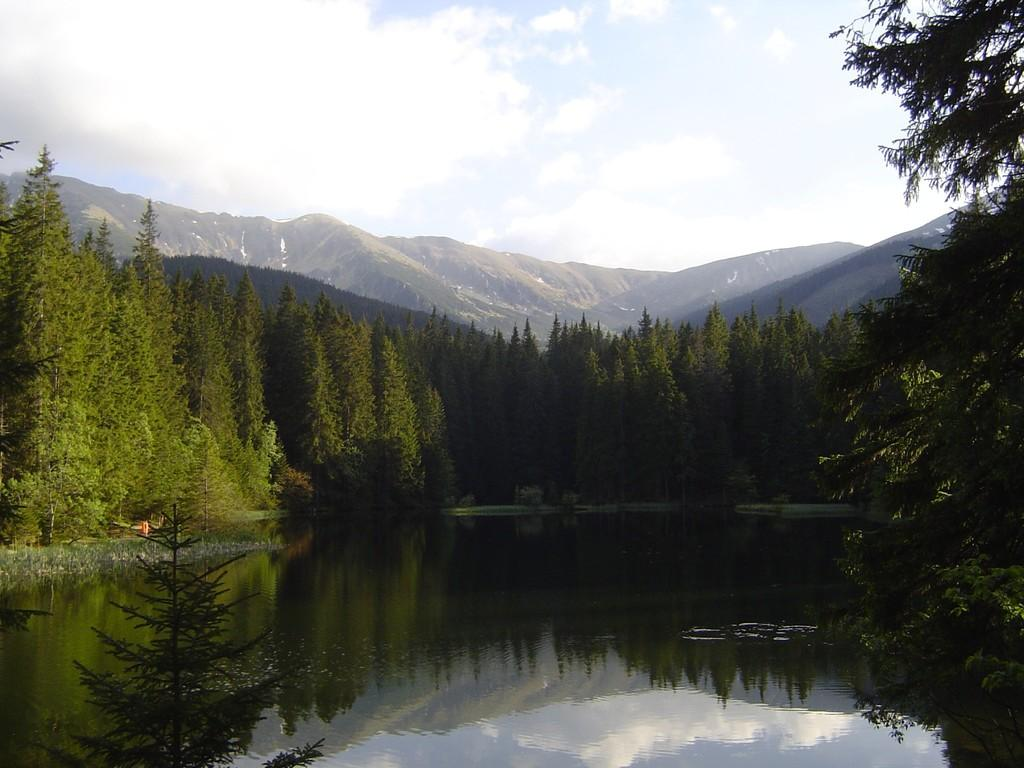What type of natural environment is depicted in the image? The image features many trees and hills, indicating a natural landscape. What can be seen in the sky in the image? The sky is visible at the top of the image, and clouds are present. What body of water is present in the image? There is a lake at the bottom of the image. How many quarters can be seen in the image? There are no quarters present in the image; it features a natural landscape with trees, hills, sky, clouds, and a lake. Can you see an owl perched on one of the trees in the image? There is no owl present in the image; it only features trees, hills, sky, clouds, and a lake. 